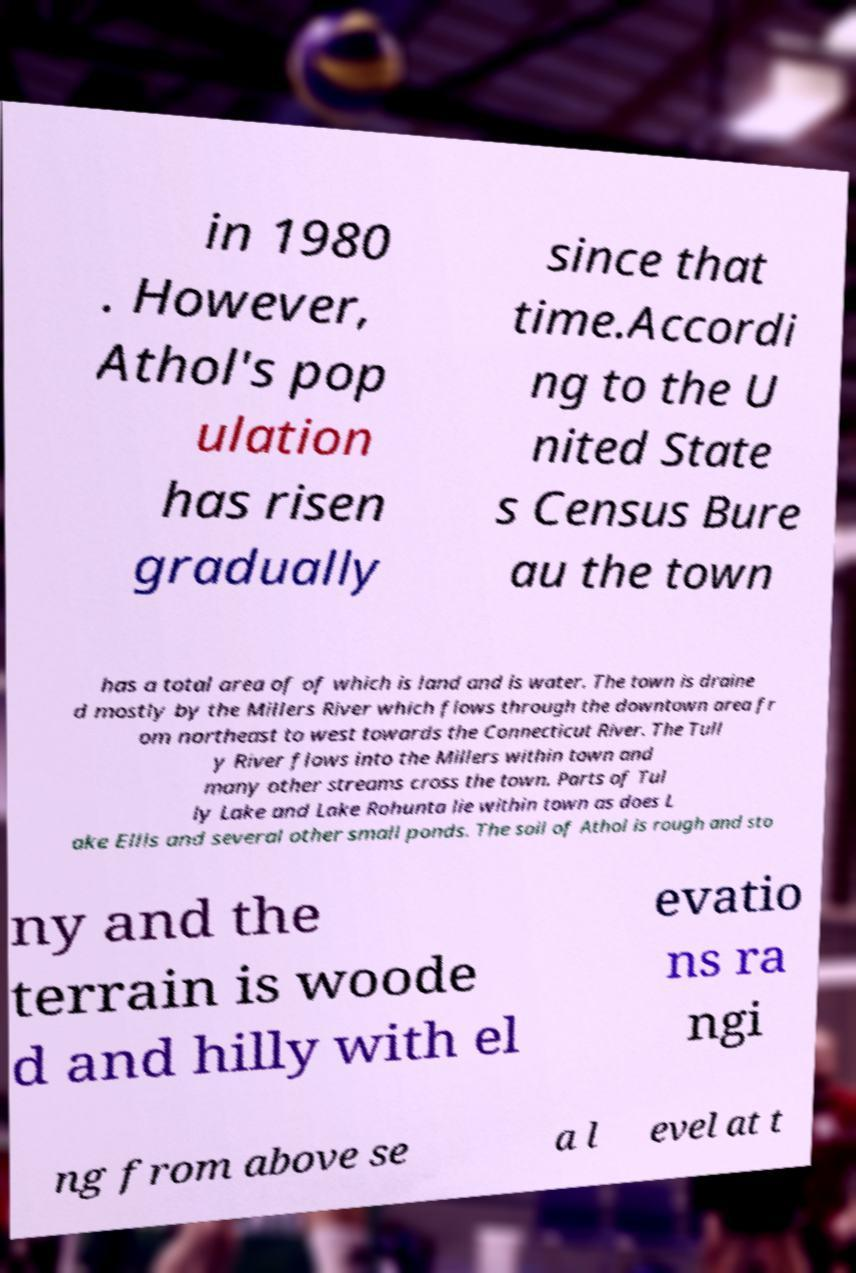Could you extract and type out the text from this image? in 1980 . However, Athol's pop ulation has risen gradually since that time.Accordi ng to the U nited State s Census Bure au the town has a total area of of which is land and is water. The town is draine d mostly by the Millers River which flows through the downtown area fr om northeast to west towards the Connecticut River. The Tull y River flows into the Millers within town and many other streams cross the town. Parts of Tul ly Lake and Lake Rohunta lie within town as does L ake Ellis and several other small ponds. The soil of Athol is rough and sto ny and the terrain is woode d and hilly with el evatio ns ra ngi ng from above se a l evel at t 